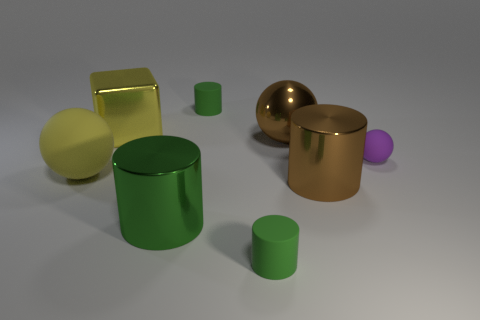Subtract all green balls. How many green cylinders are left? 3 Add 1 big green things. How many objects exist? 9 Subtract all spheres. How many objects are left? 5 Add 6 big blocks. How many big blocks exist? 7 Subtract 0 cyan cylinders. How many objects are left? 8 Subtract all big yellow matte spheres. Subtract all green metallic cylinders. How many objects are left? 6 Add 5 big green things. How many big green things are left? 6 